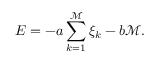<formula> <loc_0><loc_0><loc_500><loc_500>E = - a \sum _ { k = 1 } ^ { \mathcal { M } } \xi _ { k } - b { \mathcal { M } } .</formula> 